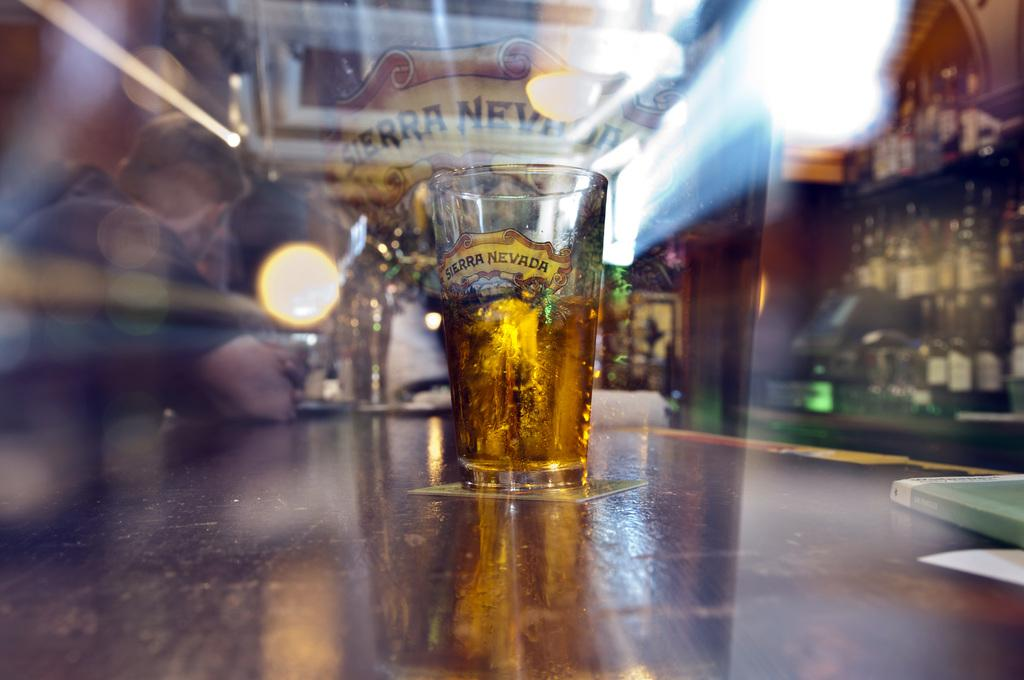<image>
Relay a brief, clear account of the picture shown. a glass on a bar that is labeled 'sierra nevada' 